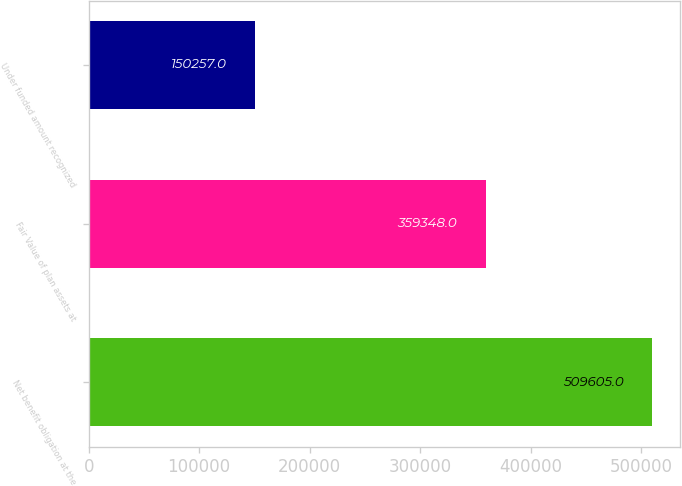<chart> <loc_0><loc_0><loc_500><loc_500><bar_chart><fcel>Net benefit obligation at the<fcel>Fair Value of plan assets at<fcel>Under funded amount recognized<nl><fcel>509605<fcel>359348<fcel>150257<nl></chart> 